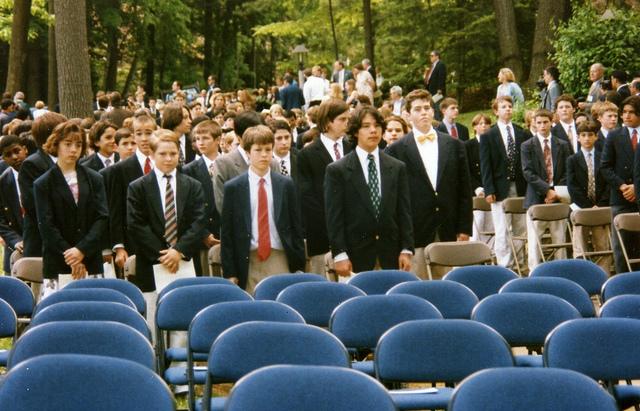Is anyone sitting?
Concise answer only. No. Is the crowd dressed nicely?
Give a very brief answer. Yes. What color are the chairs?
Quick response, please. Blue. 